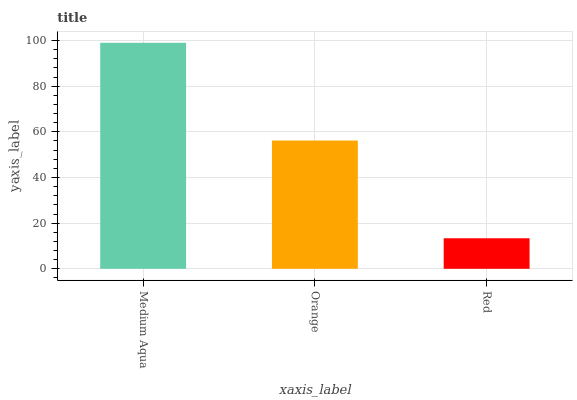Is Red the minimum?
Answer yes or no. Yes. Is Medium Aqua the maximum?
Answer yes or no. Yes. Is Orange the minimum?
Answer yes or no. No. Is Orange the maximum?
Answer yes or no. No. Is Medium Aqua greater than Orange?
Answer yes or no. Yes. Is Orange less than Medium Aqua?
Answer yes or no. Yes. Is Orange greater than Medium Aqua?
Answer yes or no. No. Is Medium Aqua less than Orange?
Answer yes or no. No. Is Orange the high median?
Answer yes or no. Yes. Is Orange the low median?
Answer yes or no. Yes. Is Medium Aqua the high median?
Answer yes or no. No. Is Medium Aqua the low median?
Answer yes or no. No. 